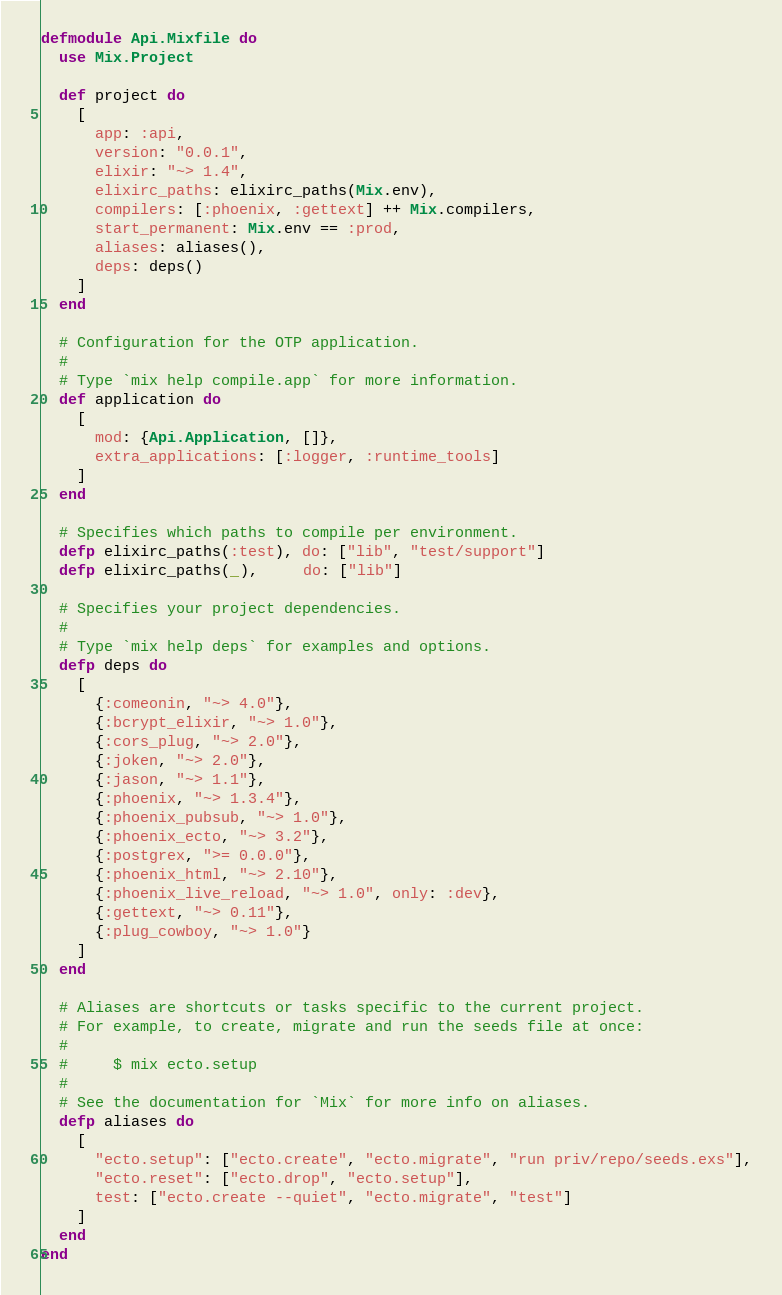<code> <loc_0><loc_0><loc_500><loc_500><_Elixir_>defmodule Api.Mixfile do
  use Mix.Project

  def project do
    [
      app: :api,
      version: "0.0.1",
      elixir: "~> 1.4",
      elixirc_paths: elixirc_paths(Mix.env),
      compilers: [:phoenix, :gettext] ++ Mix.compilers,
      start_permanent: Mix.env == :prod,
      aliases: aliases(),
      deps: deps()
    ]
  end

  # Configuration for the OTP application.
  #
  # Type `mix help compile.app` for more information.
  def application do
    [
      mod: {Api.Application, []},
      extra_applications: [:logger, :runtime_tools]
    ]
  end

  # Specifies which paths to compile per environment.
  defp elixirc_paths(:test), do: ["lib", "test/support"]
  defp elixirc_paths(_),     do: ["lib"]

  # Specifies your project dependencies.
  #
  # Type `mix help deps` for examples and options.
  defp deps do
    [
      {:comeonin, "~> 4.0"},
      {:bcrypt_elixir, "~> 1.0"},
      {:cors_plug, "~> 2.0"},
      {:joken, "~> 2.0"},
      {:jason, "~> 1.1"},
      {:phoenix, "~> 1.3.4"},
      {:phoenix_pubsub, "~> 1.0"},
      {:phoenix_ecto, "~> 3.2"},
      {:postgrex, ">= 0.0.0"},
      {:phoenix_html, "~> 2.10"},
      {:phoenix_live_reload, "~> 1.0", only: :dev},
      {:gettext, "~> 0.11"},
      {:plug_cowboy, "~> 1.0"}
    ]
  end

  # Aliases are shortcuts or tasks specific to the current project.
  # For example, to create, migrate and run the seeds file at once:
  #
  #     $ mix ecto.setup
  #
  # See the documentation for `Mix` for more info on aliases.
  defp aliases do
    [
      "ecto.setup": ["ecto.create", "ecto.migrate", "run priv/repo/seeds.exs"],
      "ecto.reset": ["ecto.drop", "ecto.setup"],
      test: ["ecto.create --quiet", "ecto.migrate", "test"]
    ]
  end
end
</code> 